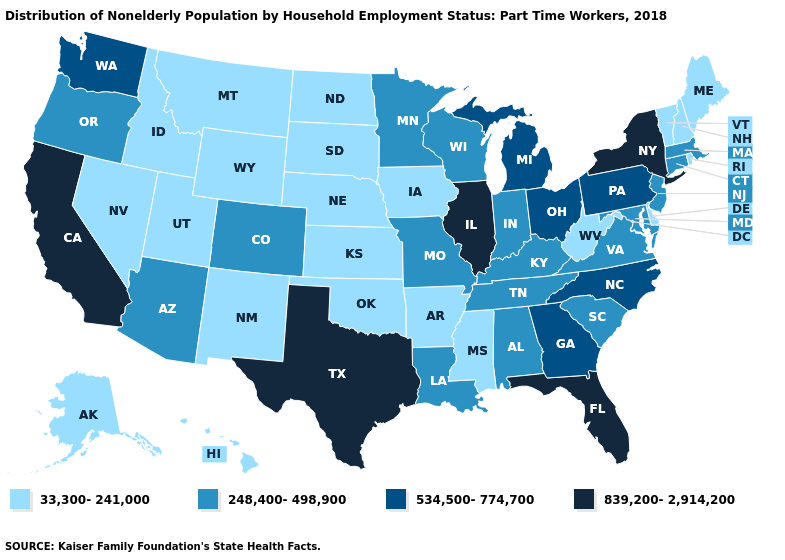Name the states that have a value in the range 248,400-498,900?
Give a very brief answer. Alabama, Arizona, Colorado, Connecticut, Indiana, Kentucky, Louisiana, Maryland, Massachusetts, Minnesota, Missouri, New Jersey, Oregon, South Carolina, Tennessee, Virginia, Wisconsin. What is the highest value in the USA?
Answer briefly. 839,200-2,914,200. Which states have the lowest value in the USA?
Be succinct. Alaska, Arkansas, Delaware, Hawaii, Idaho, Iowa, Kansas, Maine, Mississippi, Montana, Nebraska, Nevada, New Hampshire, New Mexico, North Dakota, Oklahoma, Rhode Island, South Dakota, Utah, Vermont, West Virginia, Wyoming. Name the states that have a value in the range 839,200-2,914,200?
Write a very short answer. California, Florida, Illinois, New York, Texas. Which states have the lowest value in the Northeast?
Short answer required. Maine, New Hampshire, Rhode Island, Vermont. What is the value of Rhode Island?
Quick response, please. 33,300-241,000. Does Rhode Island have a higher value than Ohio?
Answer briefly. No. Name the states that have a value in the range 839,200-2,914,200?
Keep it brief. California, Florida, Illinois, New York, Texas. Is the legend a continuous bar?
Concise answer only. No. What is the highest value in states that border New Hampshire?
Quick response, please. 248,400-498,900. What is the lowest value in the USA?
Keep it brief. 33,300-241,000. What is the value of Delaware?
Concise answer only. 33,300-241,000. Name the states that have a value in the range 33,300-241,000?
Quick response, please. Alaska, Arkansas, Delaware, Hawaii, Idaho, Iowa, Kansas, Maine, Mississippi, Montana, Nebraska, Nevada, New Hampshire, New Mexico, North Dakota, Oklahoma, Rhode Island, South Dakota, Utah, Vermont, West Virginia, Wyoming. Does the first symbol in the legend represent the smallest category?
Keep it brief. Yes. Name the states that have a value in the range 839,200-2,914,200?
Be succinct. California, Florida, Illinois, New York, Texas. 